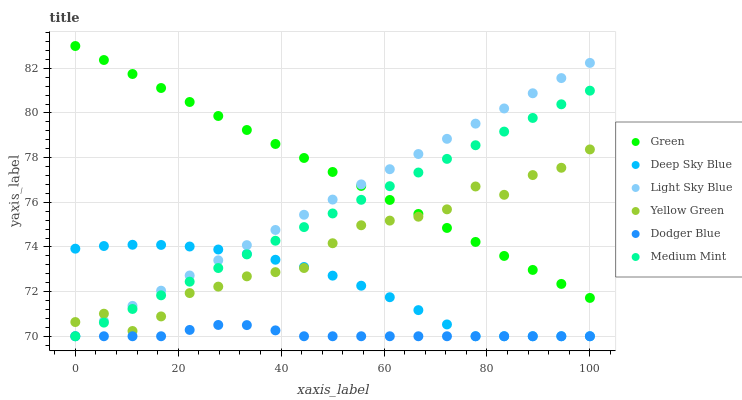Does Dodger Blue have the minimum area under the curve?
Answer yes or no. Yes. Does Green have the maximum area under the curve?
Answer yes or no. Yes. Does Yellow Green have the minimum area under the curve?
Answer yes or no. No. Does Yellow Green have the maximum area under the curve?
Answer yes or no. No. Is Light Sky Blue the smoothest?
Answer yes or no. Yes. Is Yellow Green the roughest?
Answer yes or no. Yes. Is Yellow Green the smoothest?
Answer yes or no. No. Is Light Sky Blue the roughest?
Answer yes or no. No. Does Medium Mint have the lowest value?
Answer yes or no. Yes. Does Yellow Green have the lowest value?
Answer yes or no. No. Does Green have the highest value?
Answer yes or no. Yes. Does Yellow Green have the highest value?
Answer yes or no. No. Is Dodger Blue less than Yellow Green?
Answer yes or no. Yes. Is Green greater than Deep Sky Blue?
Answer yes or no. Yes. Does Medium Mint intersect Deep Sky Blue?
Answer yes or no. Yes. Is Medium Mint less than Deep Sky Blue?
Answer yes or no. No. Is Medium Mint greater than Deep Sky Blue?
Answer yes or no. No. Does Dodger Blue intersect Yellow Green?
Answer yes or no. No. 